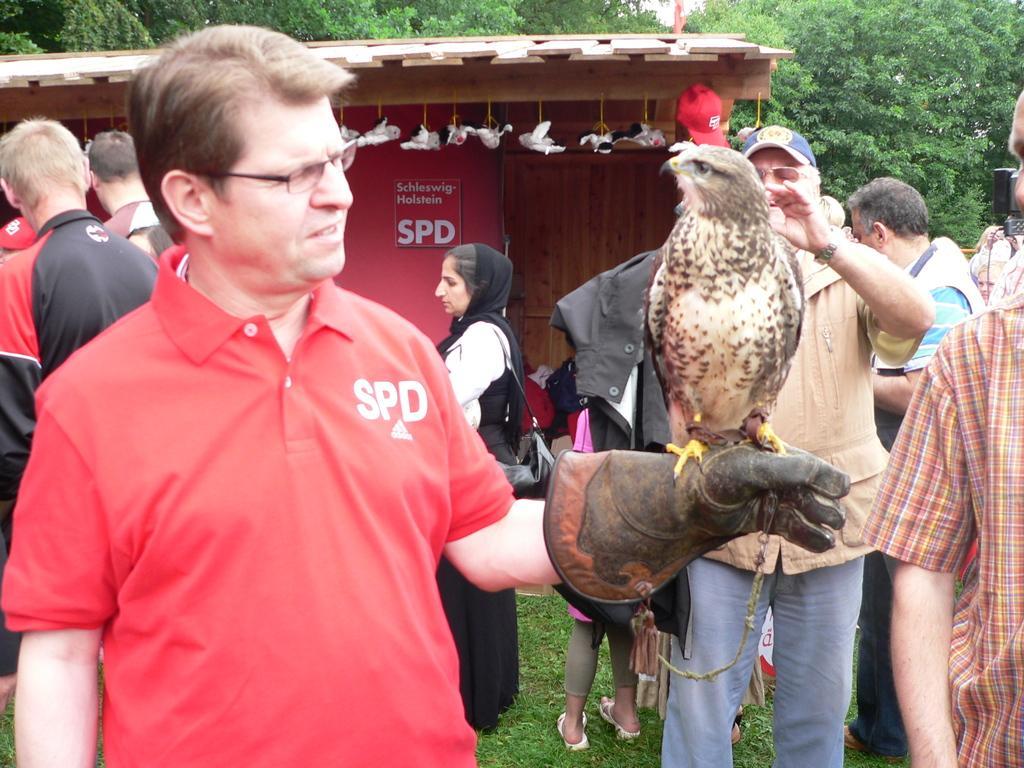Can you describe this image briefly? In this image in the front there is a person standing and there is a bird standing on the hand of the person. In the background there are persons, there's grass on the ground and there is shelter and there are trees. 